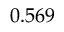<formula> <loc_0><loc_0><loc_500><loc_500>0 . 5 6 9</formula> 